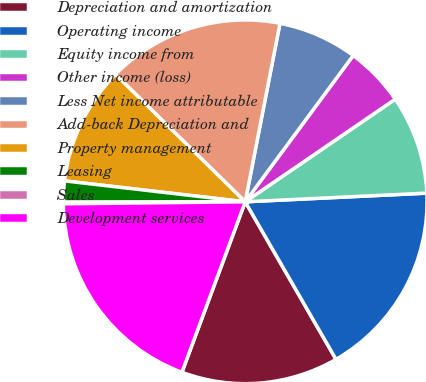Convert chart to OTSL. <chart><loc_0><loc_0><loc_500><loc_500><pie_chart><fcel>Depreciation and amortization<fcel>Operating income<fcel>Equity income from<fcel>Other income (loss)<fcel>Less Net income attributable<fcel>Add-back Depreciation and<fcel>Property management<fcel>Leasing<fcel>Sales<fcel>Development services<nl><fcel>13.98%<fcel>17.44%<fcel>8.79%<fcel>5.33%<fcel>7.06%<fcel>15.71%<fcel>10.52%<fcel>1.87%<fcel>0.14%<fcel>19.17%<nl></chart> 